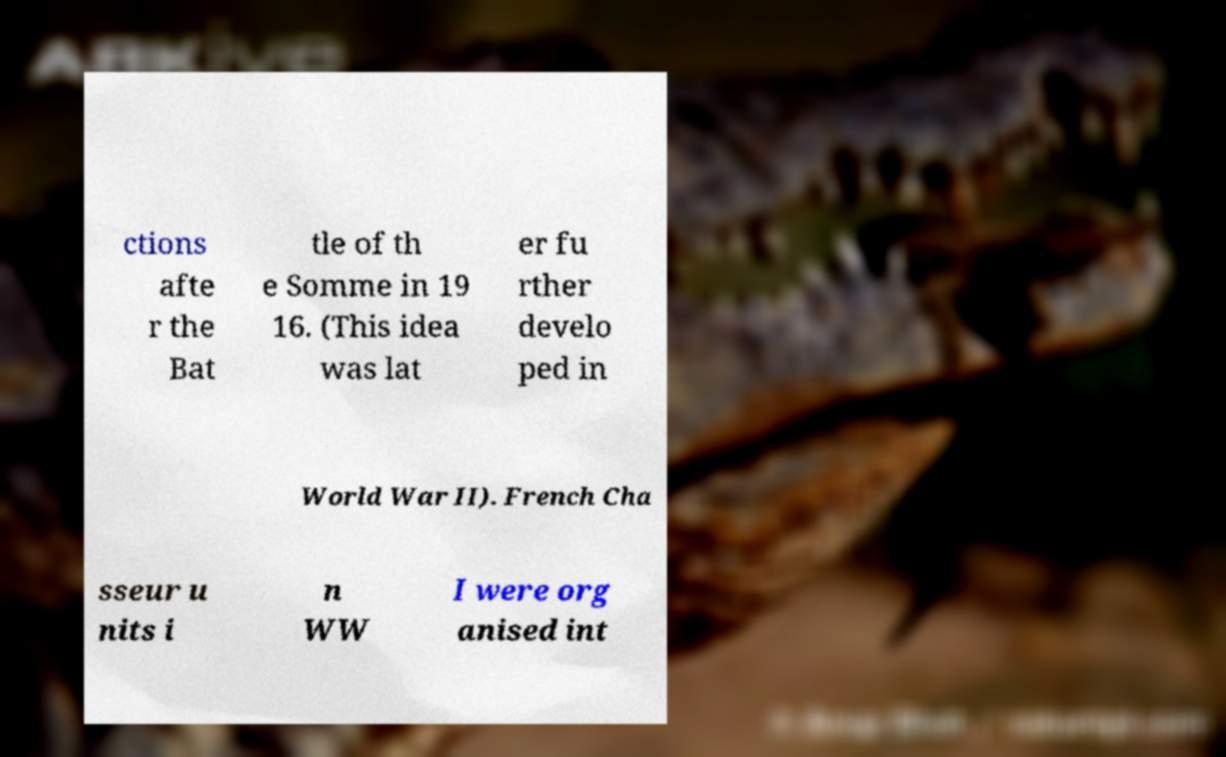For documentation purposes, I need the text within this image transcribed. Could you provide that? ctions afte r the Bat tle of th e Somme in 19 16. (This idea was lat er fu rther develo ped in World War II). French Cha sseur u nits i n WW I were org anised int 